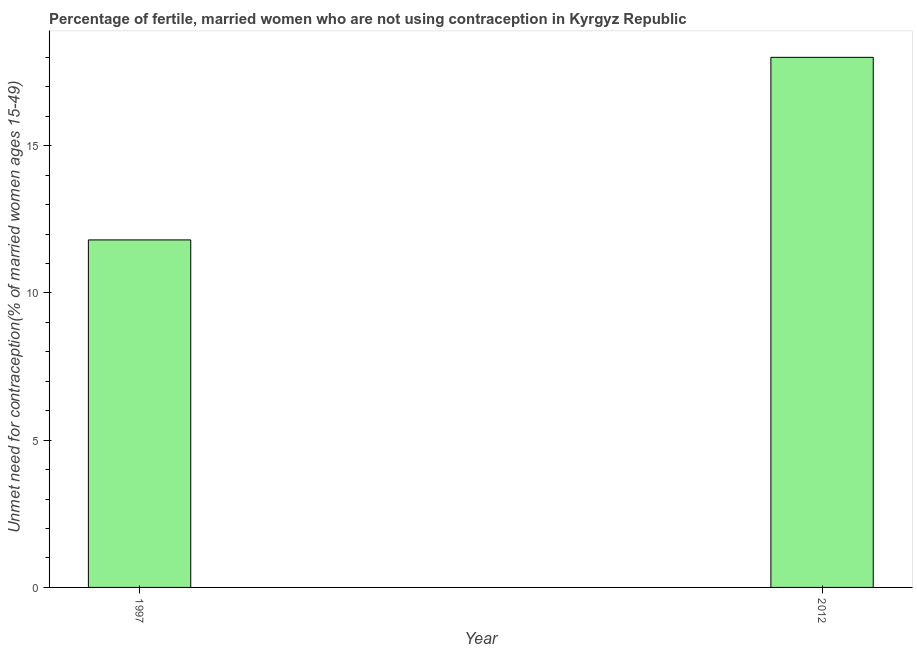Does the graph contain any zero values?
Offer a terse response. No. What is the title of the graph?
Give a very brief answer. Percentage of fertile, married women who are not using contraception in Kyrgyz Republic. What is the label or title of the Y-axis?
Provide a short and direct response.  Unmet need for contraception(% of married women ages 15-49). Across all years, what is the maximum number of married women who are not using contraception?
Ensure brevity in your answer.  18. Across all years, what is the minimum number of married women who are not using contraception?
Ensure brevity in your answer.  11.8. In which year was the number of married women who are not using contraception maximum?
Give a very brief answer. 2012. In which year was the number of married women who are not using contraception minimum?
Keep it short and to the point. 1997. What is the sum of the number of married women who are not using contraception?
Make the answer very short. 29.8. What is the difference between the number of married women who are not using contraception in 1997 and 2012?
Make the answer very short. -6.2. Do a majority of the years between 1997 and 2012 (inclusive) have number of married women who are not using contraception greater than 13 %?
Your response must be concise. No. What is the ratio of the number of married women who are not using contraception in 1997 to that in 2012?
Your answer should be compact. 0.66. Is the number of married women who are not using contraception in 1997 less than that in 2012?
Give a very brief answer. Yes. In how many years, is the number of married women who are not using contraception greater than the average number of married women who are not using contraception taken over all years?
Offer a very short reply. 1. What is the difference between two consecutive major ticks on the Y-axis?
Your response must be concise. 5. Are the values on the major ticks of Y-axis written in scientific E-notation?
Offer a terse response. No. What is the ratio of the  Unmet need for contraception(% of married women ages 15-49) in 1997 to that in 2012?
Ensure brevity in your answer.  0.66. 